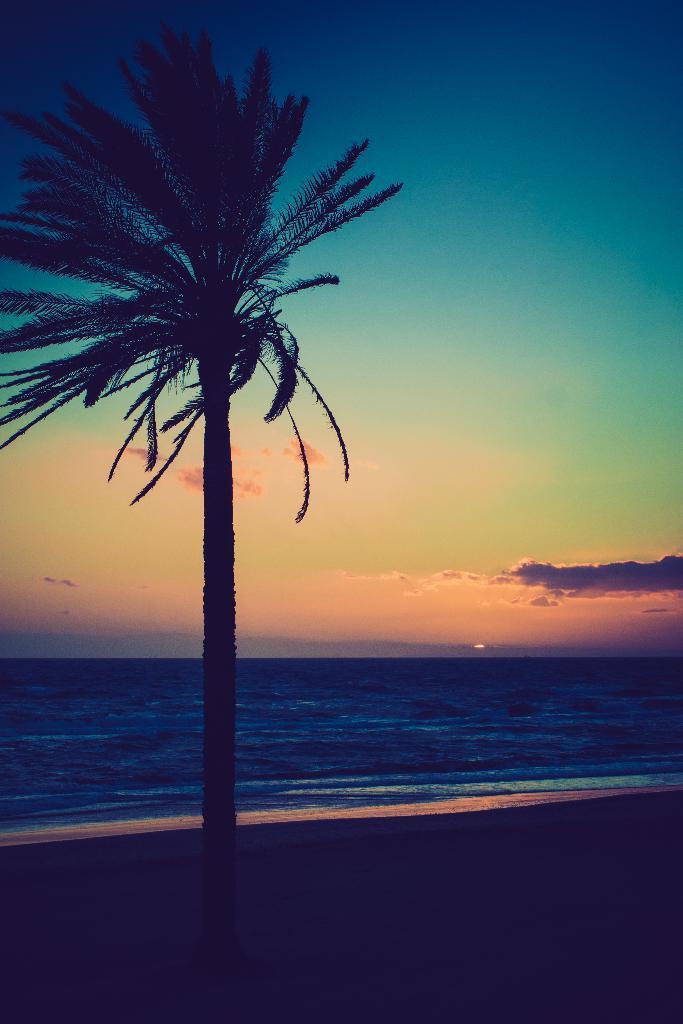How would you summarize this image in a sentence or two? There is a tree on the left side of this image and there is a sea in the background. There is a sky at the top of this image. 